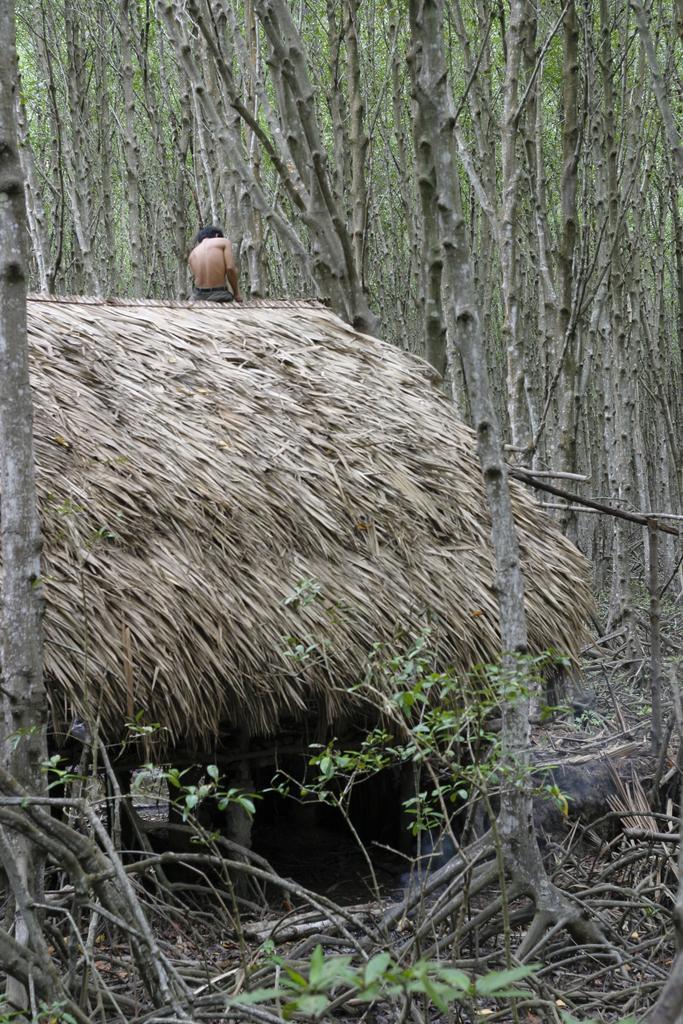Describe this image in one or two sentences. In this picture I can see the plants and sticks in front and in the middle of this picture I see a hut and I see a person. In the background I see number of trees. 